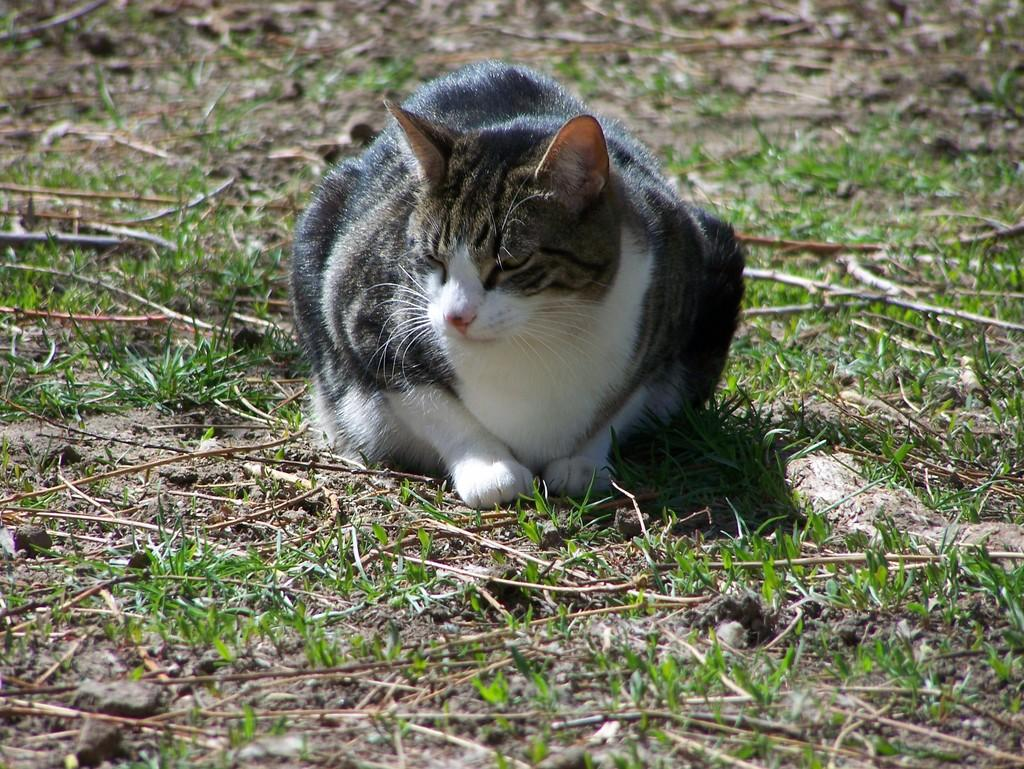What animal is in the image? There is a cat in the image. What is the cat doing in the image? The cat is sitting in the image. Where is the cat located in the image? The cat is in the center of the image. What type of surface is visible in the image? The ground is visible in the image, and it is covered with grass. What scientific experiment is being conducted with the cat in the image? There is no scientific experiment being conducted with the cat in the image; it is simply sitting. 